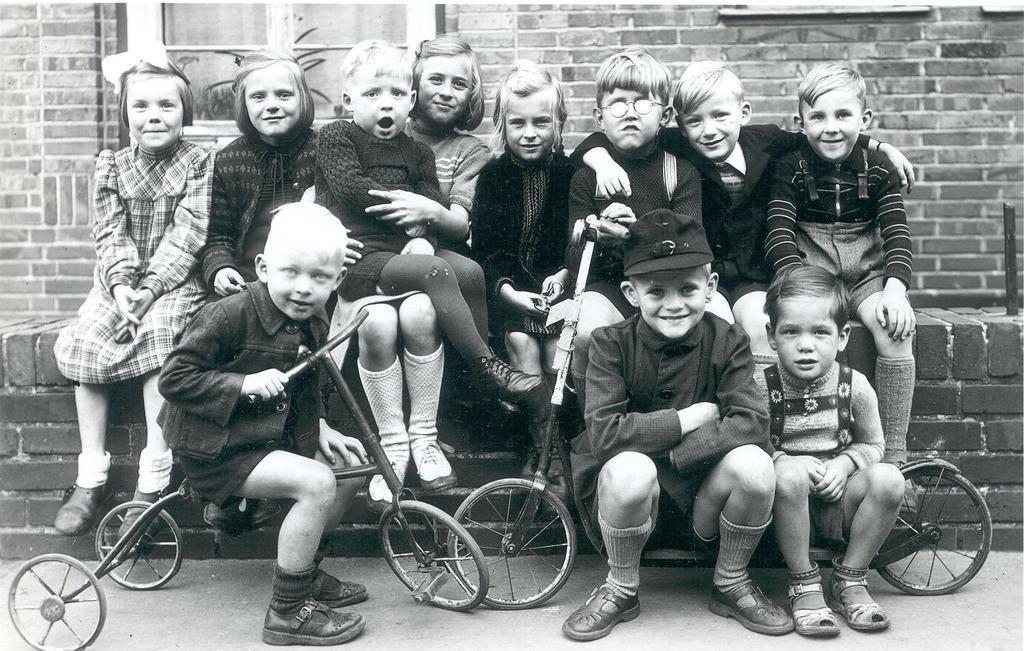In one or two sentences, can you explain what this image depicts? In this picture, there is a wall made of bricks in black color, There are some kids sitting and there are some bicycles, In the background there is a window which is in white color. 